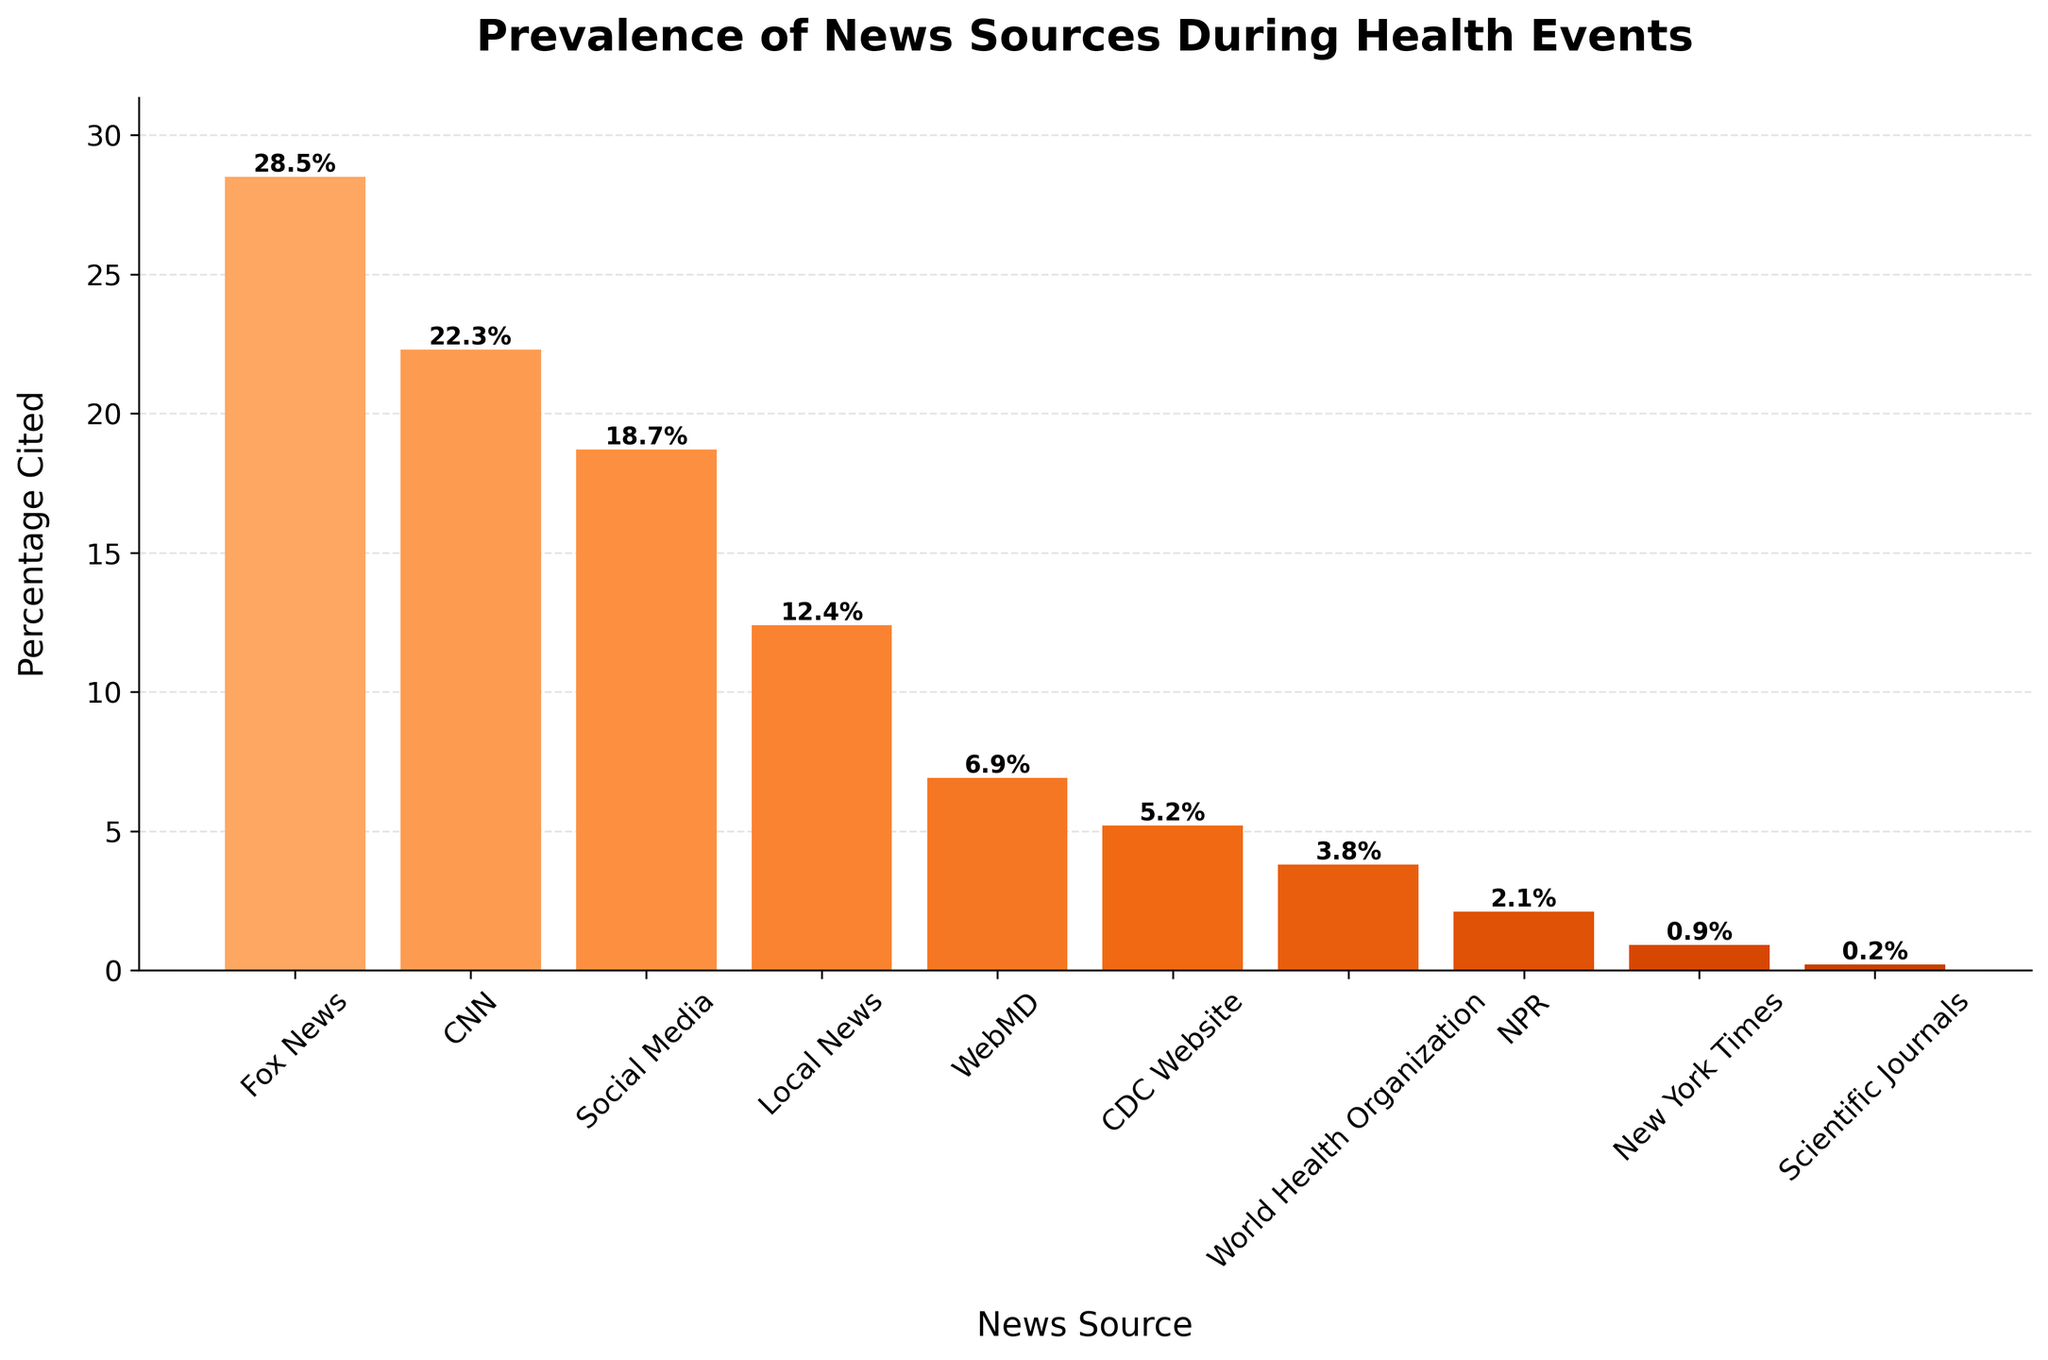Which news source has the highest percentage cited? The tallest bar in the bar chart represents the news source with the highest percentage cited. From the visual, Fox News has the highest percentage.
Answer: Fox News Which news source has the lowest percentage cited? The shortest bar in the bar chart represents the news source with the lowest percentage cited. From the visual data, Scientific Journals have the lowest percentage.
Answer: Scientific Journals What is the combined percentage cited for CNN and Social Media? To find the combined percentage, add the percentages cited for CNN and Social Media. According to the bar chart, CNN is 22.3% and Social Media is 18.7%, so 22.3 + 18.7 = 41%.
Answer: 41% How much more frequently is Fox News cited compared to the CDC Website? To find the difference, subtract the percentage cited for the CDC Website from the one for Fox News. Fox News is 28.5% and the CDC Website is 5.2%, so 28.5 - 5.2 = 23.3%.
Answer: 23.3% Are any news sources cited equally? To determine if any news sources have the same citation percentage, visually compare the heights of the bars. From the given data, all news sources have distinct bar heights.
Answer: No What is the average percentage cited for all news sources? To find the average percentage, sum all the percentages and then divide by the number of news sources. The total is 28.5 + 22.3 + 18.7 + 12.4 + 6.9 + 5.2 + 3.8 + 2.1 + 0.9 + 0.2 = 101. Then, divide 101 by 10 (number of sources): 101 / 10 = 10.1%.
Answer: 10.1% Which visual element makes it easy to compare the percentages cited for each news source? The color bars of varying heights make it simple to visually compare the percentage cited for each news source. The varying height indicates the difference in percentages.
Answer: Bars of varying heights How many news sources have a citation percentage under 10%? Count the number of bars that fall below the 10% mark on the y-axis. From the chart, these news sources are WebMD, CDC Website, World Health Organization, NPR, New York Times, and Scientific Journals, totaling six sources.
Answer: 6 